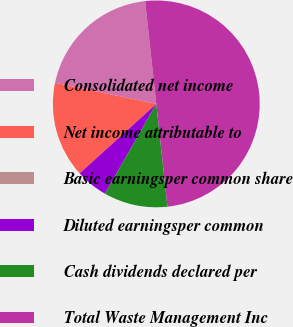Convert chart to OTSL. <chart><loc_0><loc_0><loc_500><loc_500><pie_chart><fcel>Consolidated net income<fcel>Net income attributable to<fcel>Basic earningsper common share<fcel>Diluted earningsper common<fcel>Cash dividends declared per<fcel>Total Waste Management Inc<nl><fcel>20.0%<fcel>15.0%<fcel>0.0%<fcel>5.0%<fcel>10.0%<fcel>50.0%<nl></chart> 